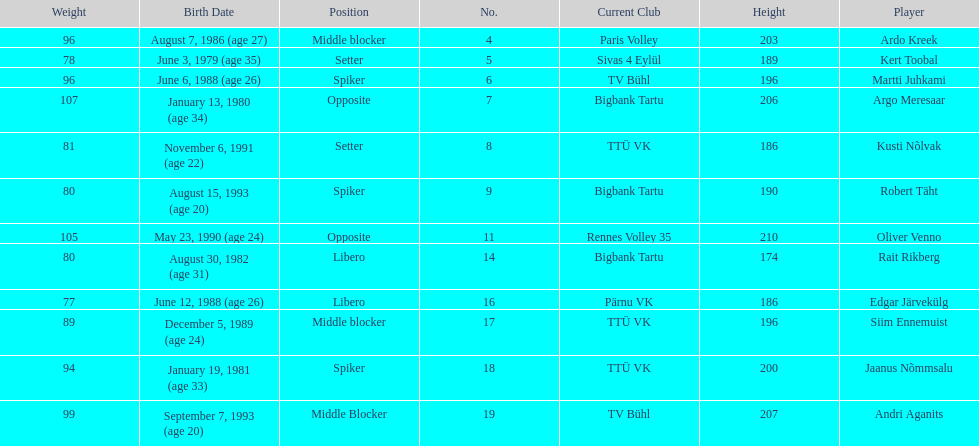Kert toobal is the oldest who is the next oldest player listed? Argo Meresaar. 